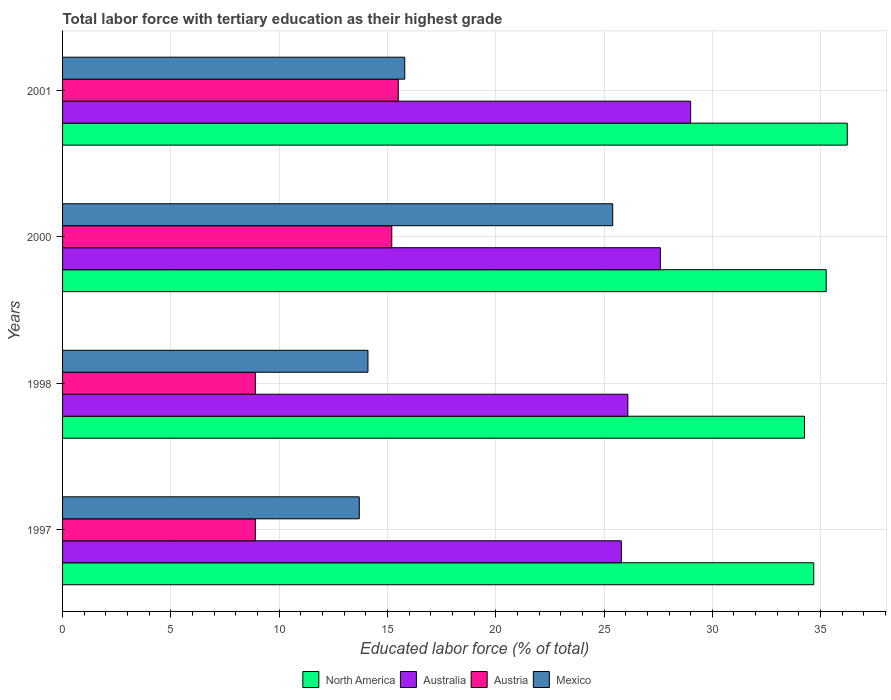How many groups of bars are there?
Offer a terse response. 4. Are the number of bars per tick equal to the number of legend labels?
Offer a very short reply. Yes. How many bars are there on the 1st tick from the top?
Give a very brief answer. 4. How many bars are there on the 2nd tick from the bottom?
Give a very brief answer. 4. In how many cases, is the number of bars for a given year not equal to the number of legend labels?
Your response must be concise. 0. What is the percentage of male labor force with tertiary education in Australia in 1997?
Make the answer very short. 25.8. Across all years, what is the minimum percentage of male labor force with tertiary education in Mexico?
Your answer should be compact. 13.7. In which year was the percentage of male labor force with tertiary education in Mexico maximum?
Give a very brief answer. 2000. In which year was the percentage of male labor force with tertiary education in Austria minimum?
Keep it short and to the point. 1997. What is the total percentage of male labor force with tertiary education in Mexico in the graph?
Provide a succinct answer. 69. What is the difference between the percentage of male labor force with tertiary education in North America in 1997 and that in 1998?
Provide a short and direct response. 0.43. What is the difference between the percentage of male labor force with tertiary education in Australia in 2000 and the percentage of male labor force with tertiary education in Austria in 1997?
Your answer should be very brief. 18.7. What is the average percentage of male labor force with tertiary education in North America per year?
Offer a terse response. 35.11. In the year 1998, what is the difference between the percentage of male labor force with tertiary education in North America and percentage of male labor force with tertiary education in Mexico?
Keep it short and to the point. 20.15. In how many years, is the percentage of male labor force with tertiary education in Mexico greater than 10 %?
Your response must be concise. 4. What is the ratio of the percentage of male labor force with tertiary education in Australia in 1997 to that in 2001?
Provide a succinct answer. 0.89. Is the percentage of male labor force with tertiary education in North America in 1997 less than that in 2001?
Provide a succinct answer. Yes. Is the difference between the percentage of male labor force with tertiary education in North America in 1997 and 1998 greater than the difference between the percentage of male labor force with tertiary education in Mexico in 1997 and 1998?
Provide a succinct answer. Yes. What is the difference between the highest and the second highest percentage of male labor force with tertiary education in Australia?
Keep it short and to the point. 1.4. What is the difference between the highest and the lowest percentage of male labor force with tertiary education in North America?
Ensure brevity in your answer.  1.98. In how many years, is the percentage of male labor force with tertiary education in North America greater than the average percentage of male labor force with tertiary education in North America taken over all years?
Your answer should be compact. 2. Is the sum of the percentage of male labor force with tertiary education in North America in 1997 and 1998 greater than the maximum percentage of male labor force with tertiary education in Austria across all years?
Provide a succinct answer. Yes. What does the 1st bar from the top in 1997 represents?
Give a very brief answer. Mexico. Is it the case that in every year, the sum of the percentage of male labor force with tertiary education in Austria and percentage of male labor force with tertiary education in North America is greater than the percentage of male labor force with tertiary education in Mexico?
Offer a terse response. Yes. How many bars are there?
Ensure brevity in your answer.  16. Are all the bars in the graph horizontal?
Offer a very short reply. Yes. What is the difference between two consecutive major ticks on the X-axis?
Make the answer very short. 5. Where does the legend appear in the graph?
Your response must be concise. Bottom center. How many legend labels are there?
Ensure brevity in your answer.  4. How are the legend labels stacked?
Offer a terse response. Horizontal. What is the title of the graph?
Your answer should be compact. Total labor force with tertiary education as their highest grade. Does "Madagascar" appear as one of the legend labels in the graph?
Offer a terse response. No. What is the label or title of the X-axis?
Offer a terse response. Educated labor force (% of total). What is the label or title of the Y-axis?
Your response must be concise. Years. What is the Educated labor force (% of total) in North America in 1997?
Your answer should be compact. 34.68. What is the Educated labor force (% of total) of Australia in 1997?
Make the answer very short. 25.8. What is the Educated labor force (% of total) in Austria in 1997?
Keep it short and to the point. 8.9. What is the Educated labor force (% of total) in Mexico in 1997?
Make the answer very short. 13.7. What is the Educated labor force (% of total) of North America in 1998?
Give a very brief answer. 34.25. What is the Educated labor force (% of total) in Australia in 1998?
Your answer should be very brief. 26.1. What is the Educated labor force (% of total) of Austria in 1998?
Your answer should be very brief. 8.9. What is the Educated labor force (% of total) of Mexico in 1998?
Keep it short and to the point. 14.1. What is the Educated labor force (% of total) in North America in 2000?
Offer a very short reply. 35.26. What is the Educated labor force (% of total) of Australia in 2000?
Your response must be concise. 27.6. What is the Educated labor force (% of total) of Austria in 2000?
Provide a short and direct response. 15.2. What is the Educated labor force (% of total) in Mexico in 2000?
Your answer should be compact. 25.4. What is the Educated labor force (% of total) of North America in 2001?
Provide a short and direct response. 36.23. What is the Educated labor force (% of total) of Austria in 2001?
Provide a short and direct response. 15.5. What is the Educated labor force (% of total) of Mexico in 2001?
Give a very brief answer. 15.8. Across all years, what is the maximum Educated labor force (% of total) in North America?
Make the answer very short. 36.23. Across all years, what is the maximum Educated labor force (% of total) in Australia?
Your answer should be very brief. 29. Across all years, what is the maximum Educated labor force (% of total) of Mexico?
Offer a terse response. 25.4. Across all years, what is the minimum Educated labor force (% of total) in North America?
Your answer should be very brief. 34.25. Across all years, what is the minimum Educated labor force (% of total) in Australia?
Provide a short and direct response. 25.8. Across all years, what is the minimum Educated labor force (% of total) in Austria?
Provide a short and direct response. 8.9. Across all years, what is the minimum Educated labor force (% of total) of Mexico?
Make the answer very short. 13.7. What is the total Educated labor force (% of total) in North America in the graph?
Offer a terse response. 140.42. What is the total Educated labor force (% of total) in Australia in the graph?
Your response must be concise. 108.5. What is the total Educated labor force (% of total) of Austria in the graph?
Offer a very short reply. 48.5. What is the total Educated labor force (% of total) of Mexico in the graph?
Make the answer very short. 69. What is the difference between the Educated labor force (% of total) of North America in 1997 and that in 1998?
Keep it short and to the point. 0.43. What is the difference between the Educated labor force (% of total) in Austria in 1997 and that in 1998?
Provide a short and direct response. 0. What is the difference between the Educated labor force (% of total) of Mexico in 1997 and that in 1998?
Your answer should be compact. -0.4. What is the difference between the Educated labor force (% of total) in North America in 1997 and that in 2000?
Give a very brief answer. -0.57. What is the difference between the Educated labor force (% of total) of Australia in 1997 and that in 2000?
Offer a very short reply. -1.8. What is the difference between the Educated labor force (% of total) in North America in 1997 and that in 2001?
Your answer should be very brief. -1.55. What is the difference between the Educated labor force (% of total) in Australia in 1997 and that in 2001?
Give a very brief answer. -3.2. What is the difference between the Educated labor force (% of total) in Austria in 1997 and that in 2001?
Keep it short and to the point. -6.6. What is the difference between the Educated labor force (% of total) of Mexico in 1997 and that in 2001?
Keep it short and to the point. -2.1. What is the difference between the Educated labor force (% of total) of North America in 1998 and that in 2000?
Ensure brevity in your answer.  -1. What is the difference between the Educated labor force (% of total) of Austria in 1998 and that in 2000?
Your answer should be compact. -6.3. What is the difference between the Educated labor force (% of total) in North America in 1998 and that in 2001?
Offer a very short reply. -1.98. What is the difference between the Educated labor force (% of total) in North America in 2000 and that in 2001?
Your answer should be very brief. -0.97. What is the difference between the Educated labor force (% of total) of Austria in 2000 and that in 2001?
Your response must be concise. -0.3. What is the difference between the Educated labor force (% of total) of North America in 1997 and the Educated labor force (% of total) of Australia in 1998?
Offer a very short reply. 8.58. What is the difference between the Educated labor force (% of total) in North America in 1997 and the Educated labor force (% of total) in Austria in 1998?
Offer a very short reply. 25.78. What is the difference between the Educated labor force (% of total) in North America in 1997 and the Educated labor force (% of total) in Mexico in 1998?
Ensure brevity in your answer.  20.58. What is the difference between the Educated labor force (% of total) in Australia in 1997 and the Educated labor force (% of total) in Austria in 1998?
Offer a terse response. 16.9. What is the difference between the Educated labor force (% of total) of Australia in 1997 and the Educated labor force (% of total) of Mexico in 1998?
Your answer should be very brief. 11.7. What is the difference between the Educated labor force (% of total) in North America in 1997 and the Educated labor force (% of total) in Australia in 2000?
Your response must be concise. 7.08. What is the difference between the Educated labor force (% of total) in North America in 1997 and the Educated labor force (% of total) in Austria in 2000?
Your response must be concise. 19.48. What is the difference between the Educated labor force (% of total) in North America in 1997 and the Educated labor force (% of total) in Mexico in 2000?
Make the answer very short. 9.28. What is the difference between the Educated labor force (% of total) in Australia in 1997 and the Educated labor force (% of total) in Mexico in 2000?
Provide a succinct answer. 0.4. What is the difference between the Educated labor force (% of total) in Austria in 1997 and the Educated labor force (% of total) in Mexico in 2000?
Offer a very short reply. -16.5. What is the difference between the Educated labor force (% of total) of North America in 1997 and the Educated labor force (% of total) of Australia in 2001?
Give a very brief answer. 5.68. What is the difference between the Educated labor force (% of total) in North America in 1997 and the Educated labor force (% of total) in Austria in 2001?
Ensure brevity in your answer.  19.18. What is the difference between the Educated labor force (% of total) in North America in 1997 and the Educated labor force (% of total) in Mexico in 2001?
Provide a short and direct response. 18.88. What is the difference between the Educated labor force (% of total) of Australia in 1997 and the Educated labor force (% of total) of Mexico in 2001?
Your answer should be very brief. 10. What is the difference between the Educated labor force (% of total) in North America in 1998 and the Educated labor force (% of total) in Australia in 2000?
Make the answer very short. 6.65. What is the difference between the Educated labor force (% of total) in North America in 1998 and the Educated labor force (% of total) in Austria in 2000?
Provide a short and direct response. 19.05. What is the difference between the Educated labor force (% of total) in North America in 1998 and the Educated labor force (% of total) in Mexico in 2000?
Keep it short and to the point. 8.85. What is the difference between the Educated labor force (% of total) in Australia in 1998 and the Educated labor force (% of total) in Mexico in 2000?
Keep it short and to the point. 0.7. What is the difference between the Educated labor force (% of total) in Austria in 1998 and the Educated labor force (% of total) in Mexico in 2000?
Offer a terse response. -16.5. What is the difference between the Educated labor force (% of total) of North America in 1998 and the Educated labor force (% of total) of Australia in 2001?
Offer a terse response. 5.25. What is the difference between the Educated labor force (% of total) in North America in 1998 and the Educated labor force (% of total) in Austria in 2001?
Offer a terse response. 18.75. What is the difference between the Educated labor force (% of total) in North America in 1998 and the Educated labor force (% of total) in Mexico in 2001?
Your answer should be compact. 18.45. What is the difference between the Educated labor force (% of total) in Austria in 1998 and the Educated labor force (% of total) in Mexico in 2001?
Ensure brevity in your answer.  -6.9. What is the difference between the Educated labor force (% of total) in North America in 2000 and the Educated labor force (% of total) in Australia in 2001?
Your answer should be very brief. 6.26. What is the difference between the Educated labor force (% of total) in North America in 2000 and the Educated labor force (% of total) in Austria in 2001?
Give a very brief answer. 19.76. What is the difference between the Educated labor force (% of total) of North America in 2000 and the Educated labor force (% of total) of Mexico in 2001?
Provide a short and direct response. 19.46. What is the difference between the Educated labor force (% of total) in Australia in 2000 and the Educated labor force (% of total) in Mexico in 2001?
Offer a terse response. 11.8. What is the difference between the Educated labor force (% of total) of Austria in 2000 and the Educated labor force (% of total) of Mexico in 2001?
Offer a terse response. -0.6. What is the average Educated labor force (% of total) of North America per year?
Make the answer very short. 35.11. What is the average Educated labor force (% of total) of Australia per year?
Give a very brief answer. 27.12. What is the average Educated labor force (% of total) of Austria per year?
Your answer should be compact. 12.12. What is the average Educated labor force (% of total) of Mexico per year?
Offer a very short reply. 17.25. In the year 1997, what is the difference between the Educated labor force (% of total) in North America and Educated labor force (% of total) in Australia?
Make the answer very short. 8.88. In the year 1997, what is the difference between the Educated labor force (% of total) in North America and Educated labor force (% of total) in Austria?
Ensure brevity in your answer.  25.78. In the year 1997, what is the difference between the Educated labor force (% of total) of North America and Educated labor force (% of total) of Mexico?
Keep it short and to the point. 20.98. In the year 1997, what is the difference between the Educated labor force (% of total) in Australia and Educated labor force (% of total) in Austria?
Offer a very short reply. 16.9. In the year 1997, what is the difference between the Educated labor force (% of total) of Australia and Educated labor force (% of total) of Mexico?
Give a very brief answer. 12.1. In the year 1998, what is the difference between the Educated labor force (% of total) of North America and Educated labor force (% of total) of Australia?
Give a very brief answer. 8.15. In the year 1998, what is the difference between the Educated labor force (% of total) of North America and Educated labor force (% of total) of Austria?
Keep it short and to the point. 25.35. In the year 1998, what is the difference between the Educated labor force (% of total) of North America and Educated labor force (% of total) of Mexico?
Keep it short and to the point. 20.15. In the year 1998, what is the difference between the Educated labor force (% of total) of Australia and Educated labor force (% of total) of Mexico?
Your response must be concise. 12. In the year 2000, what is the difference between the Educated labor force (% of total) in North America and Educated labor force (% of total) in Australia?
Offer a very short reply. 7.66. In the year 2000, what is the difference between the Educated labor force (% of total) in North America and Educated labor force (% of total) in Austria?
Make the answer very short. 20.06. In the year 2000, what is the difference between the Educated labor force (% of total) in North America and Educated labor force (% of total) in Mexico?
Give a very brief answer. 9.86. In the year 2000, what is the difference between the Educated labor force (% of total) of Australia and Educated labor force (% of total) of Mexico?
Provide a succinct answer. 2.2. In the year 2001, what is the difference between the Educated labor force (% of total) of North America and Educated labor force (% of total) of Australia?
Your answer should be compact. 7.23. In the year 2001, what is the difference between the Educated labor force (% of total) of North America and Educated labor force (% of total) of Austria?
Give a very brief answer. 20.73. In the year 2001, what is the difference between the Educated labor force (% of total) in North America and Educated labor force (% of total) in Mexico?
Make the answer very short. 20.43. In the year 2001, what is the difference between the Educated labor force (% of total) of Australia and Educated labor force (% of total) of Austria?
Make the answer very short. 13.5. In the year 2001, what is the difference between the Educated labor force (% of total) in Australia and Educated labor force (% of total) in Mexico?
Offer a terse response. 13.2. In the year 2001, what is the difference between the Educated labor force (% of total) of Austria and Educated labor force (% of total) of Mexico?
Make the answer very short. -0.3. What is the ratio of the Educated labor force (% of total) in North America in 1997 to that in 1998?
Offer a terse response. 1.01. What is the ratio of the Educated labor force (% of total) in Australia in 1997 to that in 1998?
Offer a very short reply. 0.99. What is the ratio of the Educated labor force (% of total) of Mexico in 1997 to that in 1998?
Provide a succinct answer. 0.97. What is the ratio of the Educated labor force (% of total) in North America in 1997 to that in 2000?
Keep it short and to the point. 0.98. What is the ratio of the Educated labor force (% of total) in Australia in 1997 to that in 2000?
Make the answer very short. 0.93. What is the ratio of the Educated labor force (% of total) of Austria in 1997 to that in 2000?
Your response must be concise. 0.59. What is the ratio of the Educated labor force (% of total) of Mexico in 1997 to that in 2000?
Your answer should be very brief. 0.54. What is the ratio of the Educated labor force (% of total) in North America in 1997 to that in 2001?
Offer a very short reply. 0.96. What is the ratio of the Educated labor force (% of total) of Australia in 1997 to that in 2001?
Ensure brevity in your answer.  0.89. What is the ratio of the Educated labor force (% of total) in Austria in 1997 to that in 2001?
Make the answer very short. 0.57. What is the ratio of the Educated labor force (% of total) of Mexico in 1997 to that in 2001?
Provide a short and direct response. 0.87. What is the ratio of the Educated labor force (% of total) of North America in 1998 to that in 2000?
Offer a terse response. 0.97. What is the ratio of the Educated labor force (% of total) of Australia in 1998 to that in 2000?
Offer a very short reply. 0.95. What is the ratio of the Educated labor force (% of total) in Austria in 1998 to that in 2000?
Offer a very short reply. 0.59. What is the ratio of the Educated labor force (% of total) in Mexico in 1998 to that in 2000?
Provide a succinct answer. 0.56. What is the ratio of the Educated labor force (% of total) of North America in 1998 to that in 2001?
Your answer should be very brief. 0.95. What is the ratio of the Educated labor force (% of total) of Austria in 1998 to that in 2001?
Keep it short and to the point. 0.57. What is the ratio of the Educated labor force (% of total) in Mexico in 1998 to that in 2001?
Your response must be concise. 0.89. What is the ratio of the Educated labor force (% of total) in North America in 2000 to that in 2001?
Make the answer very short. 0.97. What is the ratio of the Educated labor force (% of total) in Australia in 2000 to that in 2001?
Keep it short and to the point. 0.95. What is the ratio of the Educated labor force (% of total) of Austria in 2000 to that in 2001?
Keep it short and to the point. 0.98. What is the ratio of the Educated labor force (% of total) of Mexico in 2000 to that in 2001?
Give a very brief answer. 1.61. What is the difference between the highest and the second highest Educated labor force (% of total) in North America?
Offer a very short reply. 0.97. What is the difference between the highest and the second highest Educated labor force (% of total) in Australia?
Give a very brief answer. 1.4. What is the difference between the highest and the second highest Educated labor force (% of total) of Mexico?
Make the answer very short. 9.6. What is the difference between the highest and the lowest Educated labor force (% of total) of North America?
Offer a very short reply. 1.98. 